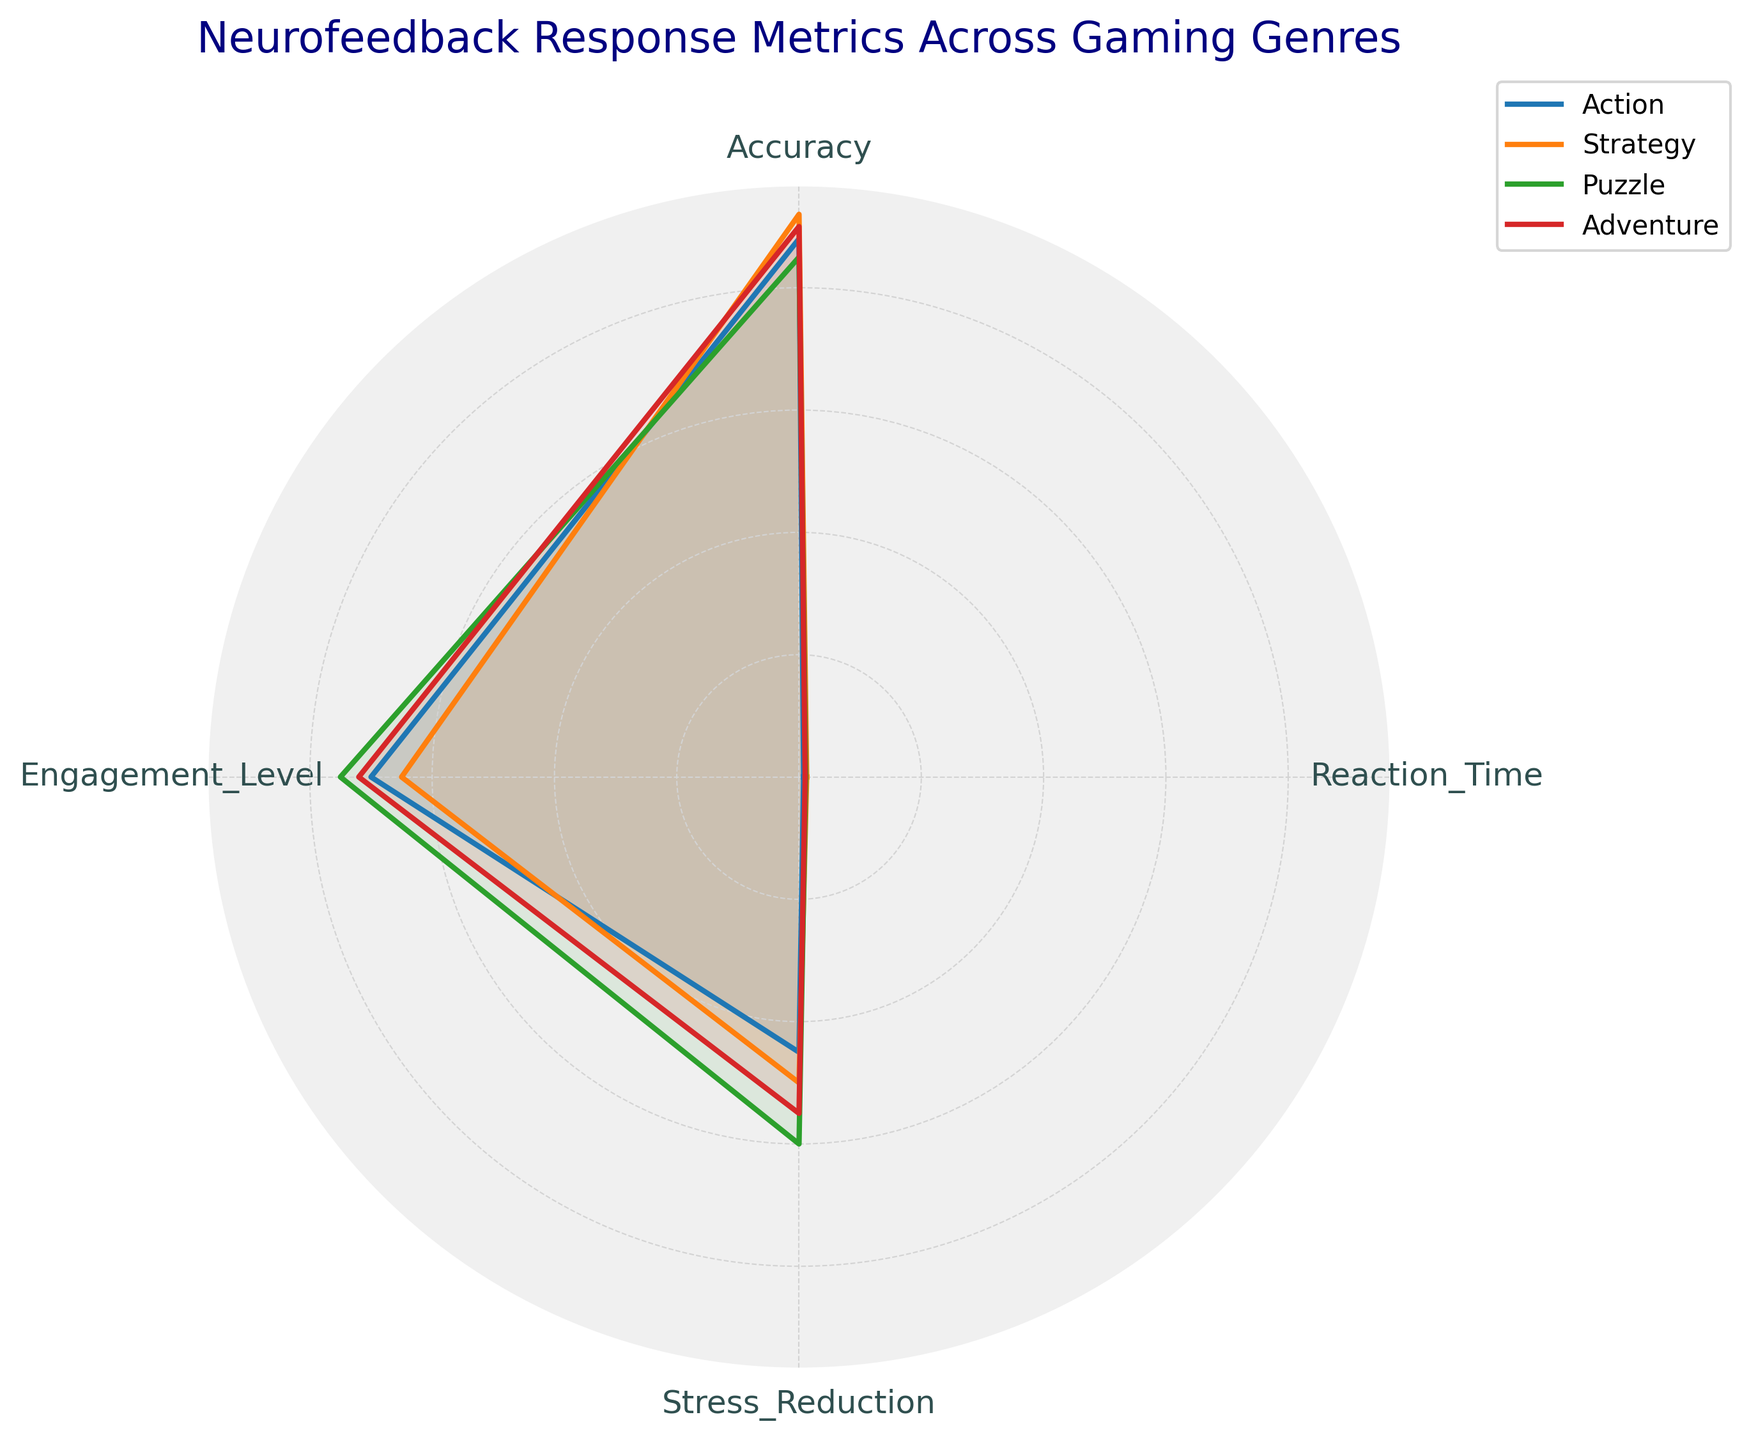What's the title of the chart? The title is located at the top of the chart, which provides an overview of what the chart represents.
Answer: Neurofeedback Response Metrics Across Gaming Genres How many game genres are represented in the chart? By looking at the legend, we can count the number of game genres included in the chart.
Answer: 4 Which game genre has the highest accuracy? By examining the radial axis related to Accuracy and comparing the values for each genre, we can see which one has the highest value.
Answer: Strategy Which game genre shows the lowest reaction time? By observing the radial axis for Reaction Time and noting the lowest value among the genres, we can identify the genre with the lowest reaction time.
Answer: Action What's the difference in engagement level between Puzzle and Adventure genres? Locate the points corresponding to Engagement Level for both Puzzle and Adventure genres, subtract the smaller value from the larger value to find the difference.
Answer: 3 Which game genre depicts the highest stress reduction? Look at the Stress Reduction axis and compare the values among the genres to identify the highest one.
Answer: Puzzle How do the engagement levels of Action and Puzzle genres compare? Check the values for Engagement Level of both Action and Puzzle genres and compare them directly to see which is higher.
Answer: Puzzle > Action Are there any genres with an equal number of metrics on any axis? Examine each metric axis (Reaction Time, Accuracy, Engagement Level, Stress Reduction) to see if any two or more genres share the same value.
Answer: No Which genre appears to have the most balanced metrics across all four attributes? To determine this, observe each genre's plot closely to see which one forms the most symmetrical shape, indicating a balance among the metrics.
Answer: Adventure 